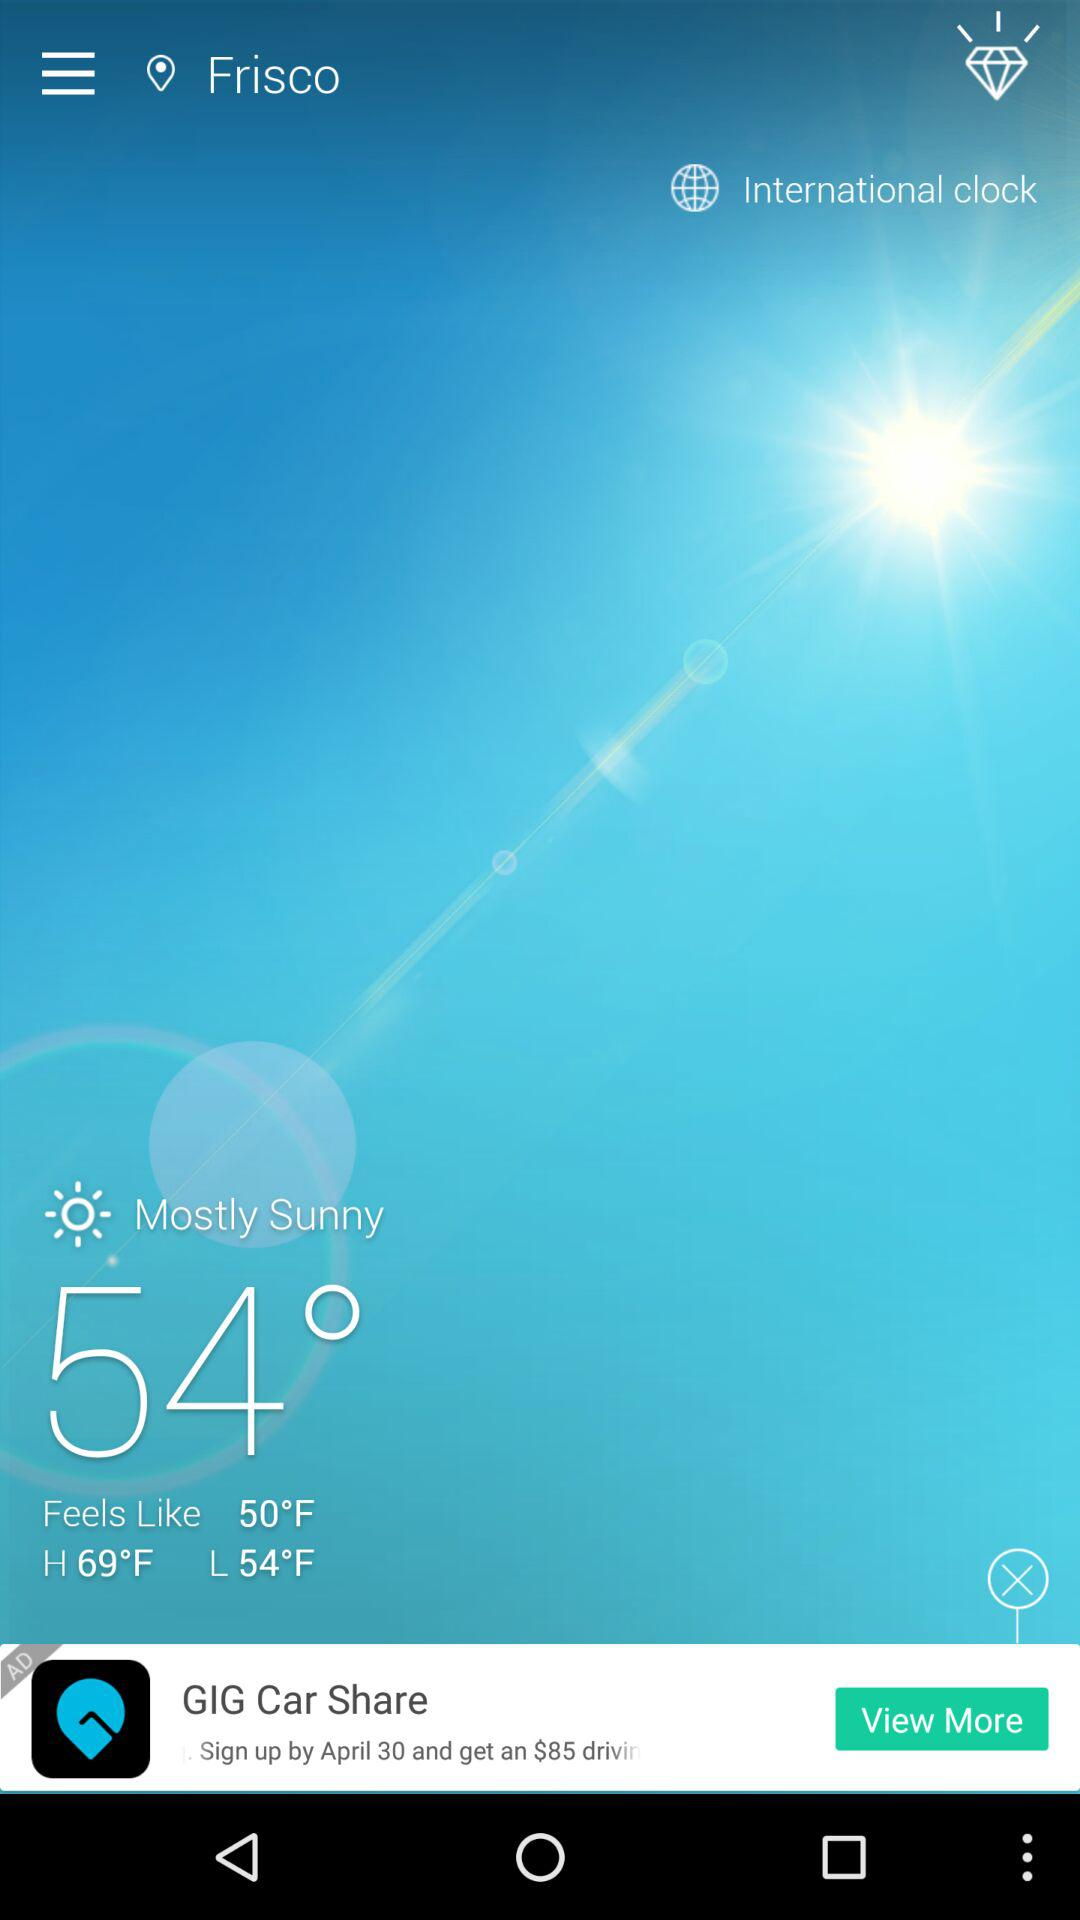How much it Feels like? It Feels like 50°F. 